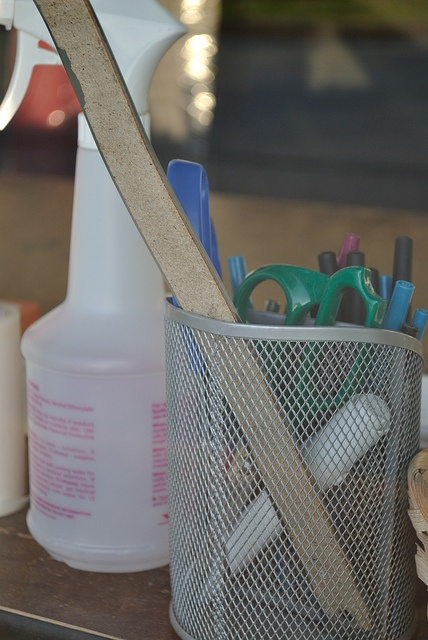Describe the objects in this image and their specific colors. I can see bottle in black, darkgray, lightgray, and gray tones, scissors in lightgray, teal, gray, darkgray, and black tones, and scissors in lightgray, gray, blue, and darkgray tones in this image. 